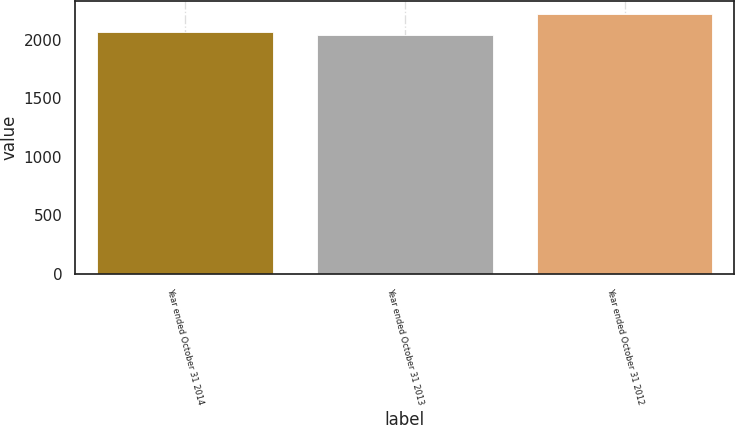Convert chart to OTSL. <chart><loc_0><loc_0><loc_500><loc_500><bar_chart><fcel>Year ended October 31 2014<fcel>Year ended October 31 2013<fcel>Year ended October 31 2012<nl><fcel>2070<fcel>2043<fcel>2218<nl></chart> 